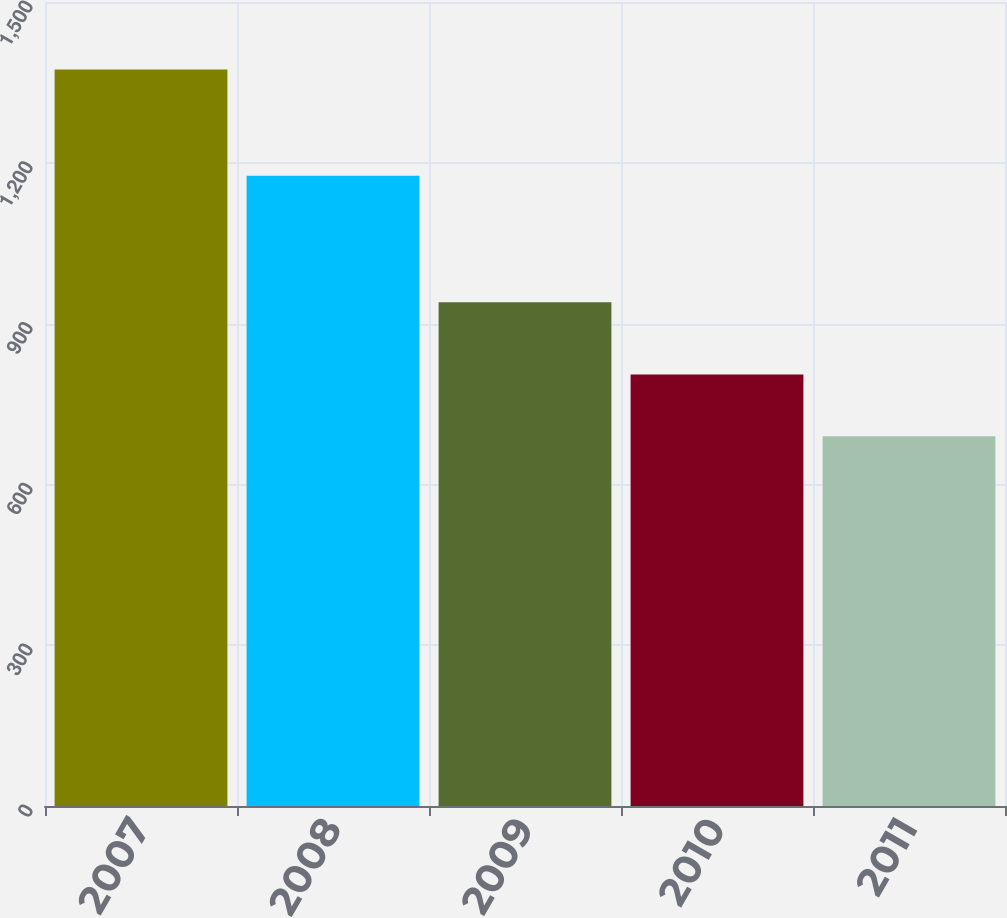Convert chart. <chart><loc_0><loc_0><loc_500><loc_500><bar_chart><fcel>2007<fcel>2008<fcel>2009<fcel>2010<fcel>2011<nl><fcel>1374<fcel>1176<fcel>940<fcel>805<fcel>690<nl></chart> 